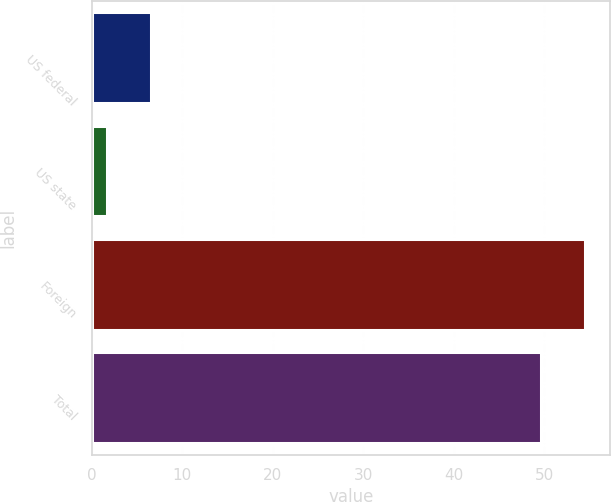<chart> <loc_0><loc_0><loc_500><loc_500><bar_chart><fcel>US federal<fcel>US state<fcel>Foreign<fcel>Total<nl><fcel>6.62<fcel>1.7<fcel>54.52<fcel>49.6<nl></chart> 